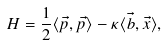<formula> <loc_0><loc_0><loc_500><loc_500>H = \frac { 1 } { 2 } \langle \vec { p } , \vec { p } \rangle - \kappa \langle \vec { b } , \vec { x } \rangle ,</formula> 